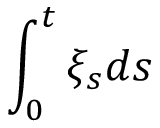<formula> <loc_0><loc_0><loc_500><loc_500>\int _ { 0 } ^ { t } \xi _ { s } d s</formula> 